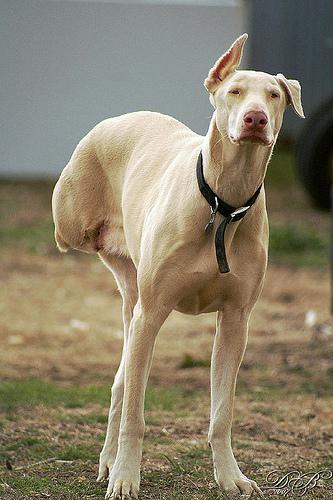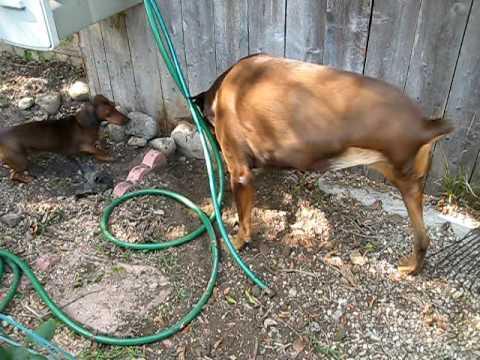The first image is the image on the left, the second image is the image on the right. Given the left and right images, does the statement "Each image includes a black-and-tan dog that is standing upright and is missing one limb." hold true? Answer yes or no. No. The first image is the image on the left, the second image is the image on the right. For the images shown, is this caption "At least one of the dogs appears to be missing a back leg." true? Answer yes or no. Yes. 